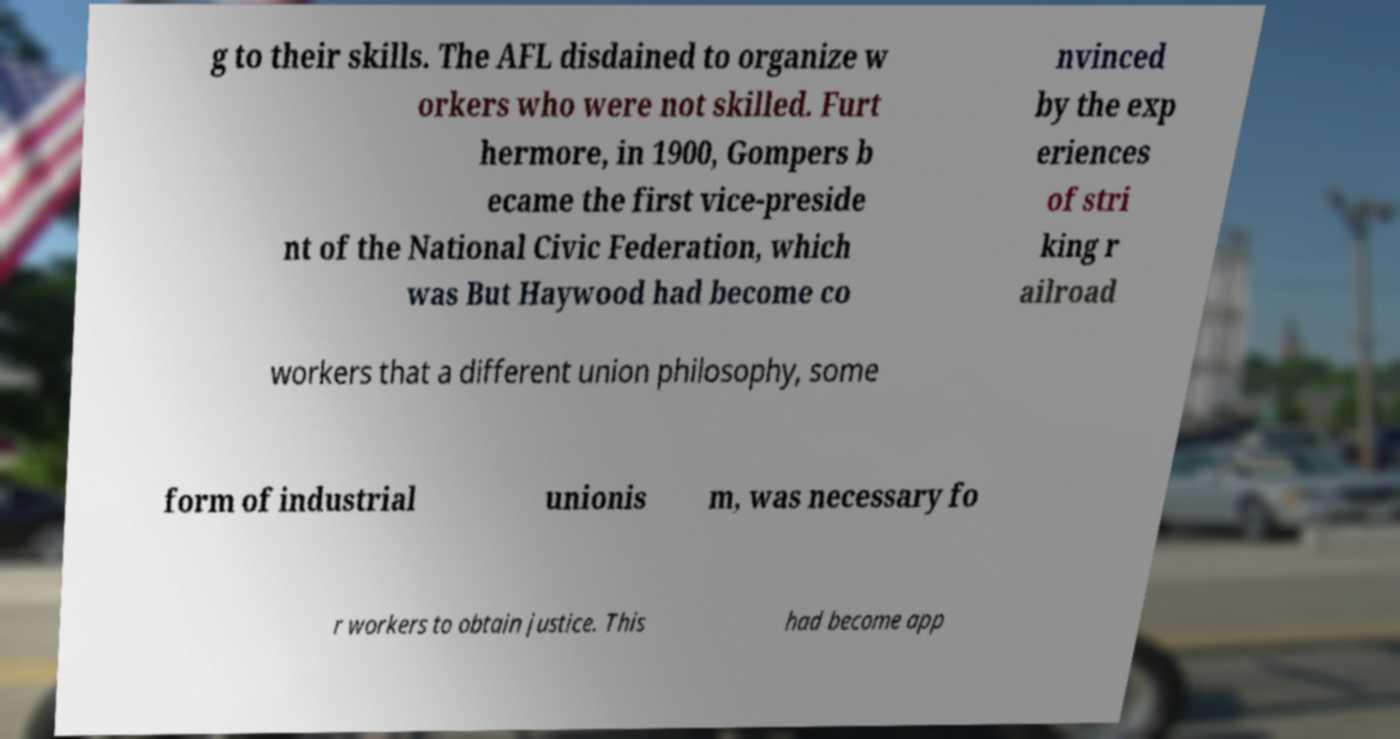There's text embedded in this image that I need extracted. Can you transcribe it verbatim? g to their skills. The AFL disdained to organize w orkers who were not skilled. Furt hermore, in 1900, Gompers b ecame the first vice-preside nt of the National Civic Federation, which was But Haywood had become co nvinced by the exp eriences of stri king r ailroad workers that a different union philosophy, some form of industrial unionis m, was necessary fo r workers to obtain justice. This had become app 